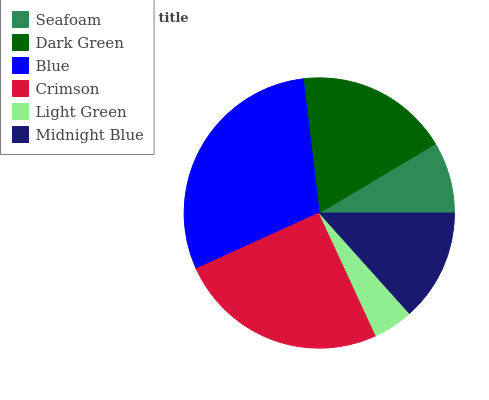Is Light Green the minimum?
Answer yes or no. Yes. Is Blue the maximum?
Answer yes or no. Yes. Is Dark Green the minimum?
Answer yes or no. No. Is Dark Green the maximum?
Answer yes or no. No. Is Dark Green greater than Seafoam?
Answer yes or no. Yes. Is Seafoam less than Dark Green?
Answer yes or no. Yes. Is Seafoam greater than Dark Green?
Answer yes or no. No. Is Dark Green less than Seafoam?
Answer yes or no. No. Is Dark Green the high median?
Answer yes or no. Yes. Is Midnight Blue the low median?
Answer yes or no. Yes. Is Blue the high median?
Answer yes or no. No. Is Light Green the low median?
Answer yes or no. No. 